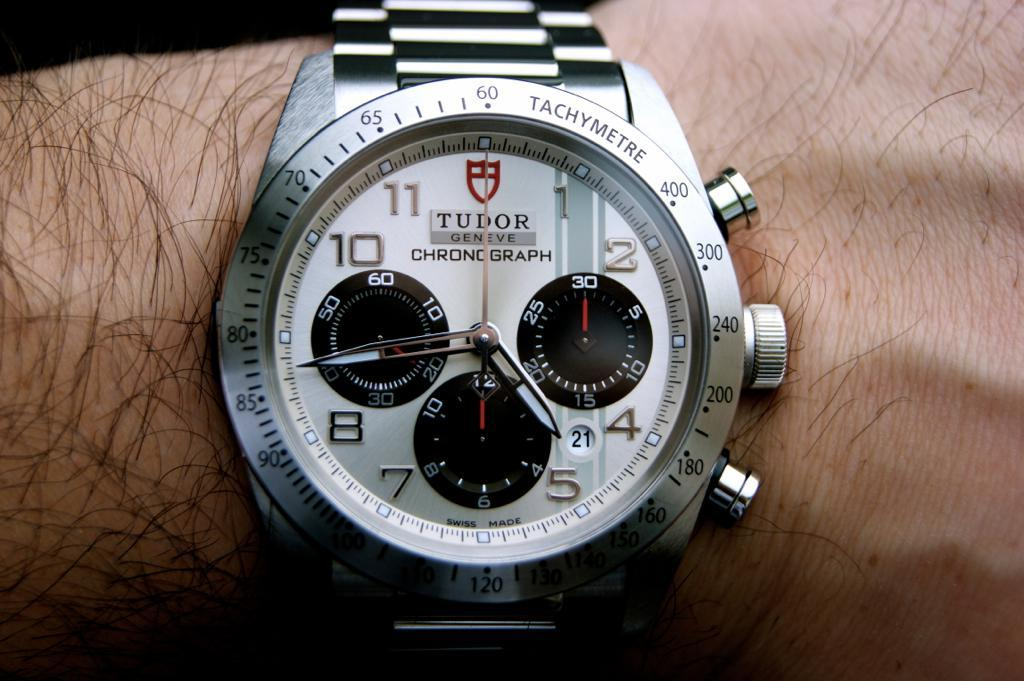<image>
Provide a brief description of the given image. A silver Tudor watch shows the time of 4:44. 